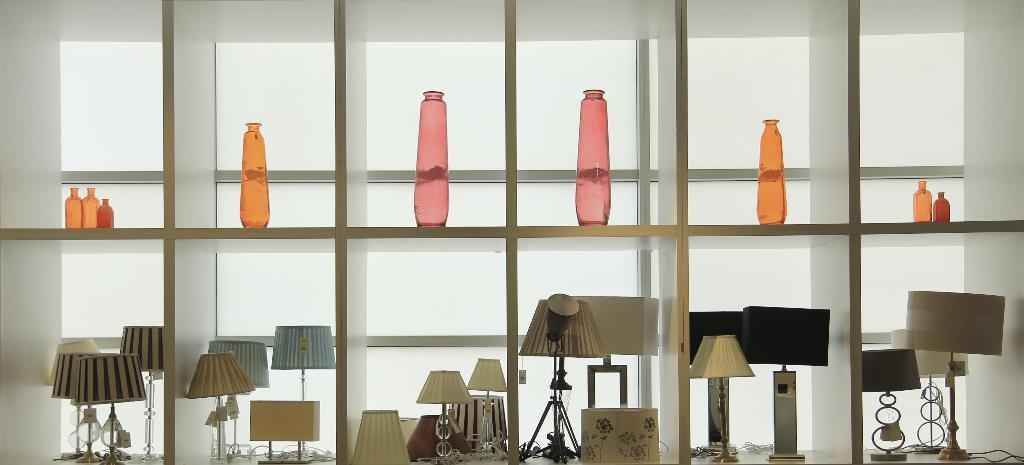What type of structure can be seen in the image? There is a wall in the image. What type of furniture is present in the image? There are cupboards in the image. What type of lighting is visible in the image? Lamps are visible in the image. How are the bottles arranged in the image? Bottles are organized on the shelves in the image. Can you see a snail crawling on the wall in the image? There is no snail present in the image. What type of zipper can be seen on the lamps in the image? There are no zippers on the lamps in the image. 